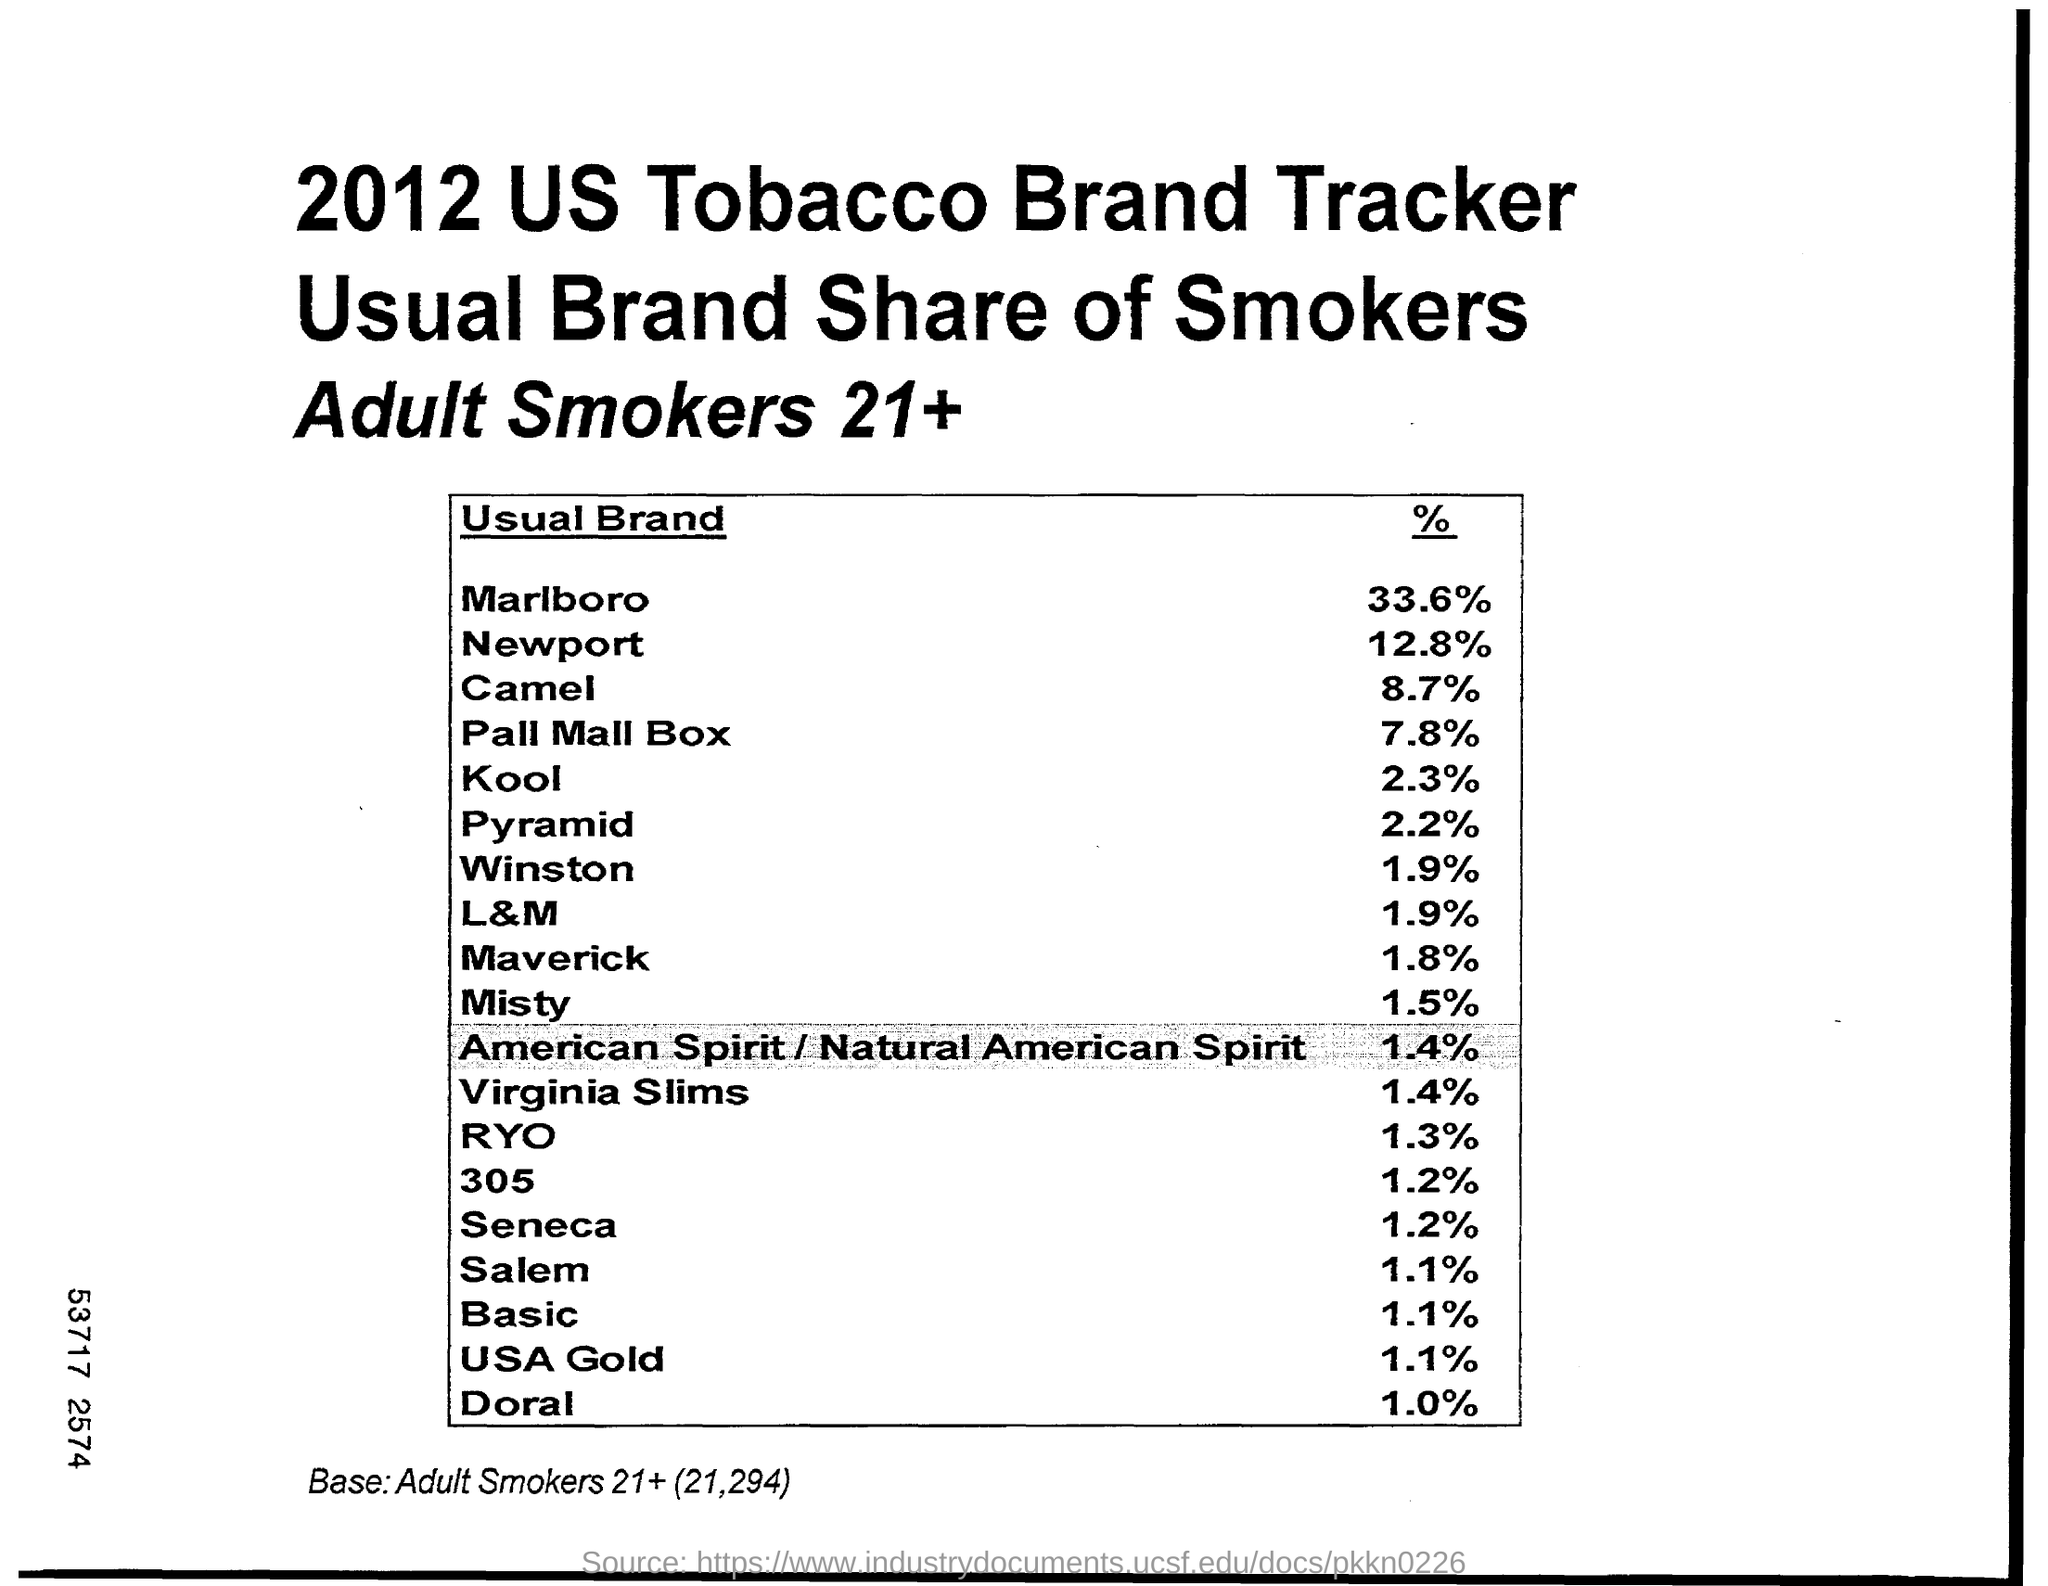What is the percentage of Usual Brand "Camel"?
Your answer should be compact. 8.7%. What is the percentage of Usual Brand "Salem"?
Make the answer very short. 1.1%. 